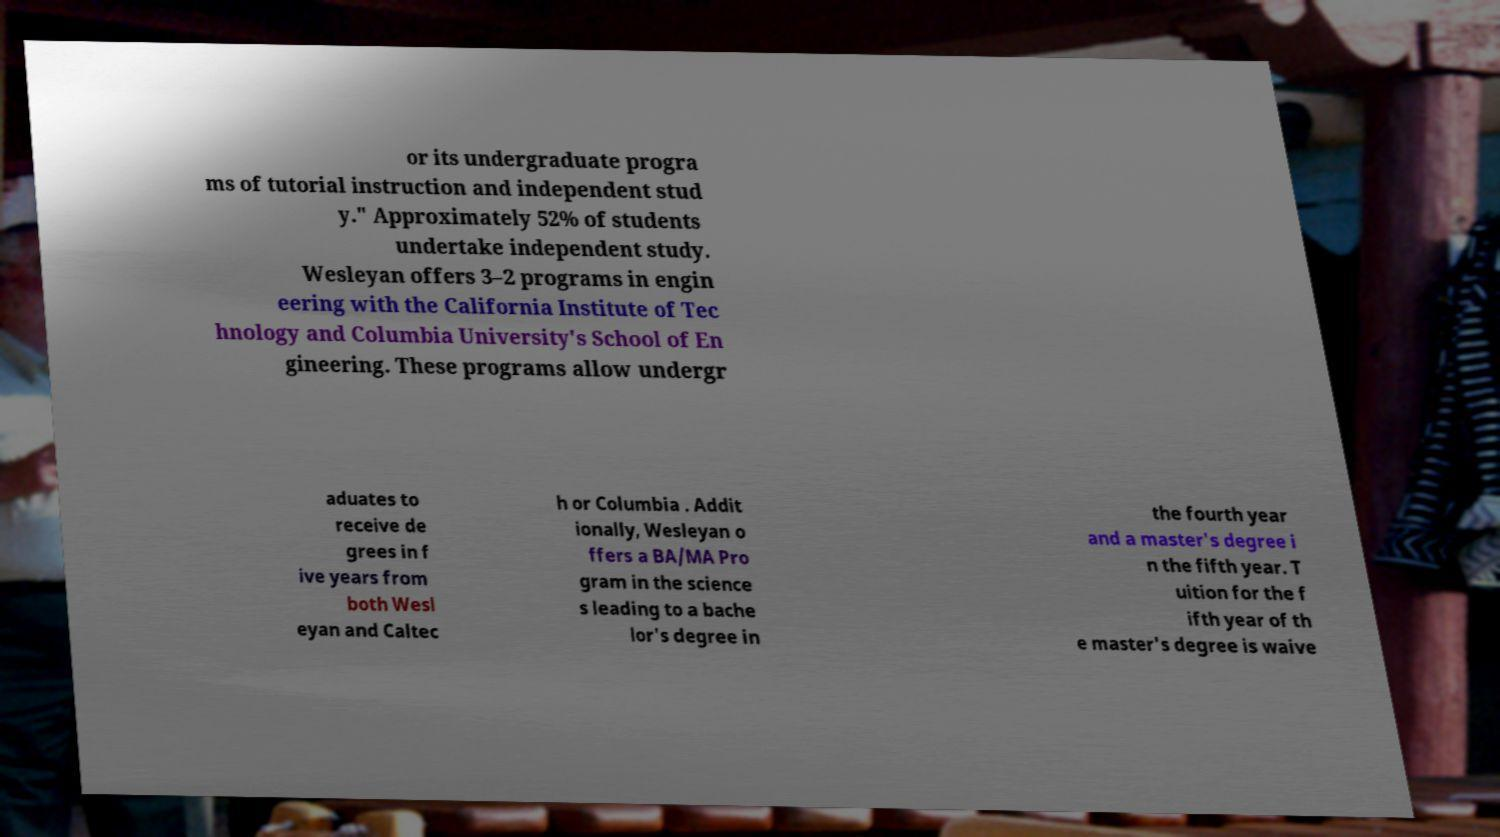Can you accurately transcribe the text from the provided image for me? or its undergraduate progra ms of tutorial instruction and independent stud y." Approximately 52% of students undertake independent study. Wesleyan offers 3–2 programs in engin eering with the California Institute of Tec hnology and Columbia University's School of En gineering. These programs allow undergr aduates to receive de grees in f ive years from both Wesl eyan and Caltec h or Columbia . Addit ionally, Wesleyan o ffers a BA/MA Pro gram in the science s leading to a bache lor's degree in the fourth year and a master's degree i n the fifth year. T uition for the f ifth year of th e master's degree is waive 